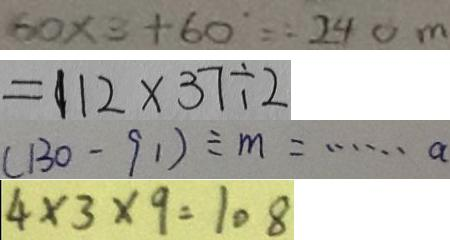Convert formula to latex. <formula><loc_0><loc_0><loc_500><loc_500>6 0 \times 3 + 6 0 = 2 4 0 n 
 = 1 1 2 \times 3 7 \div 2 
 ( 1 3 0 - 9 1 ) \div m = \cdots a 
 4 \times 3 \times 9 = 1 0 8</formula> 